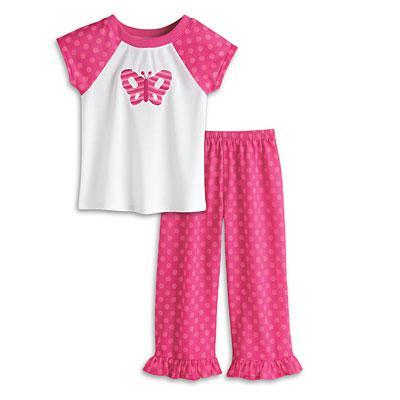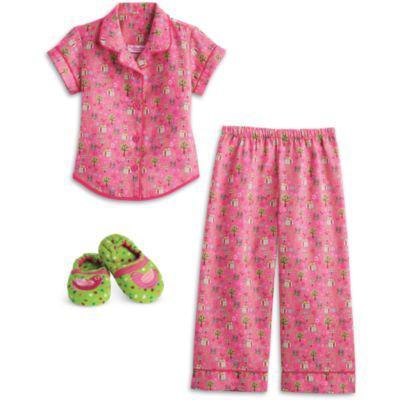The first image is the image on the left, the second image is the image on the right. Considering the images on both sides, is "One image shows a doll wearing her hair in pigtails." valid? Answer yes or no. No. The first image is the image on the left, the second image is the image on the right. Given the left and right images, does the statement "there is a doll in pajamas and wearing white bunny slippers" hold true? Answer yes or no. No. 